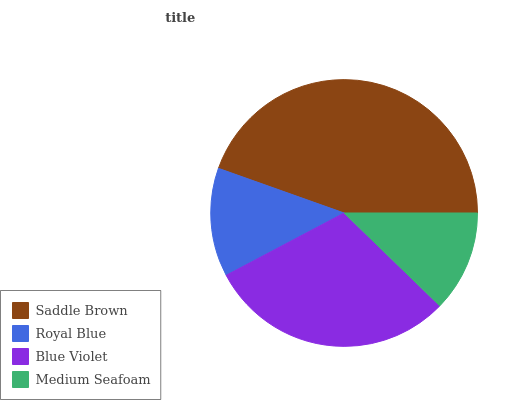Is Medium Seafoam the minimum?
Answer yes or no. Yes. Is Saddle Brown the maximum?
Answer yes or no. Yes. Is Royal Blue the minimum?
Answer yes or no. No. Is Royal Blue the maximum?
Answer yes or no. No. Is Saddle Brown greater than Royal Blue?
Answer yes or no. Yes. Is Royal Blue less than Saddle Brown?
Answer yes or no. Yes. Is Royal Blue greater than Saddle Brown?
Answer yes or no. No. Is Saddle Brown less than Royal Blue?
Answer yes or no. No. Is Blue Violet the high median?
Answer yes or no. Yes. Is Royal Blue the low median?
Answer yes or no. Yes. Is Royal Blue the high median?
Answer yes or no. No. Is Medium Seafoam the low median?
Answer yes or no. No. 